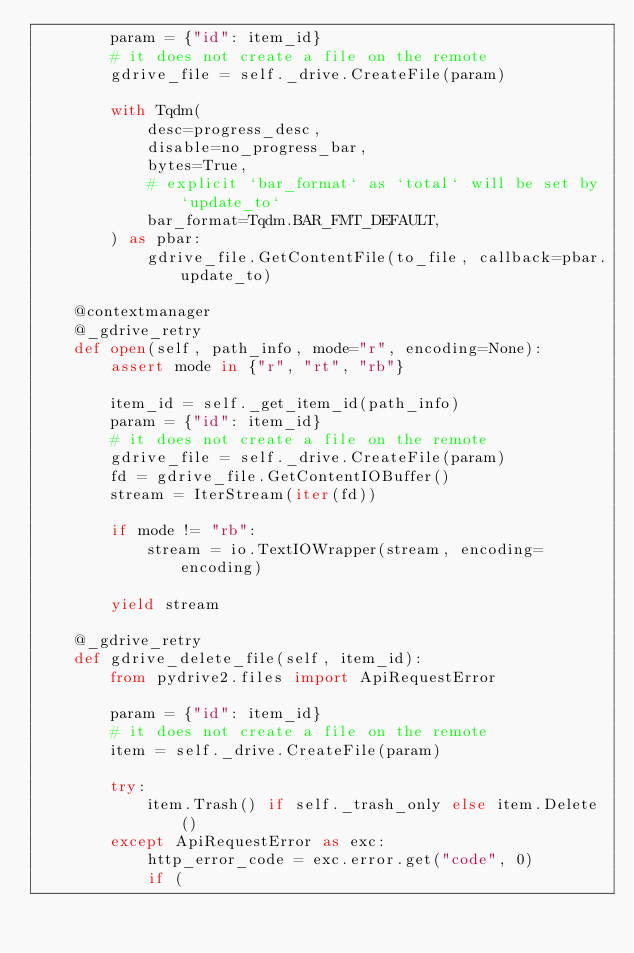<code> <loc_0><loc_0><loc_500><loc_500><_Python_>        param = {"id": item_id}
        # it does not create a file on the remote
        gdrive_file = self._drive.CreateFile(param)

        with Tqdm(
            desc=progress_desc,
            disable=no_progress_bar,
            bytes=True,
            # explicit `bar_format` as `total` will be set by `update_to`
            bar_format=Tqdm.BAR_FMT_DEFAULT,
        ) as pbar:
            gdrive_file.GetContentFile(to_file, callback=pbar.update_to)

    @contextmanager
    @_gdrive_retry
    def open(self, path_info, mode="r", encoding=None):
        assert mode in {"r", "rt", "rb"}

        item_id = self._get_item_id(path_info)
        param = {"id": item_id}
        # it does not create a file on the remote
        gdrive_file = self._drive.CreateFile(param)
        fd = gdrive_file.GetContentIOBuffer()
        stream = IterStream(iter(fd))

        if mode != "rb":
            stream = io.TextIOWrapper(stream, encoding=encoding)

        yield stream

    @_gdrive_retry
    def gdrive_delete_file(self, item_id):
        from pydrive2.files import ApiRequestError

        param = {"id": item_id}
        # it does not create a file on the remote
        item = self._drive.CreateFile(param)

        try:
            item.Trash() if self._trash_only else item.Delete()
        except ApiRequestError as exc:
            http_error_code = exc.error.get("code", 0)
            if (</code> 